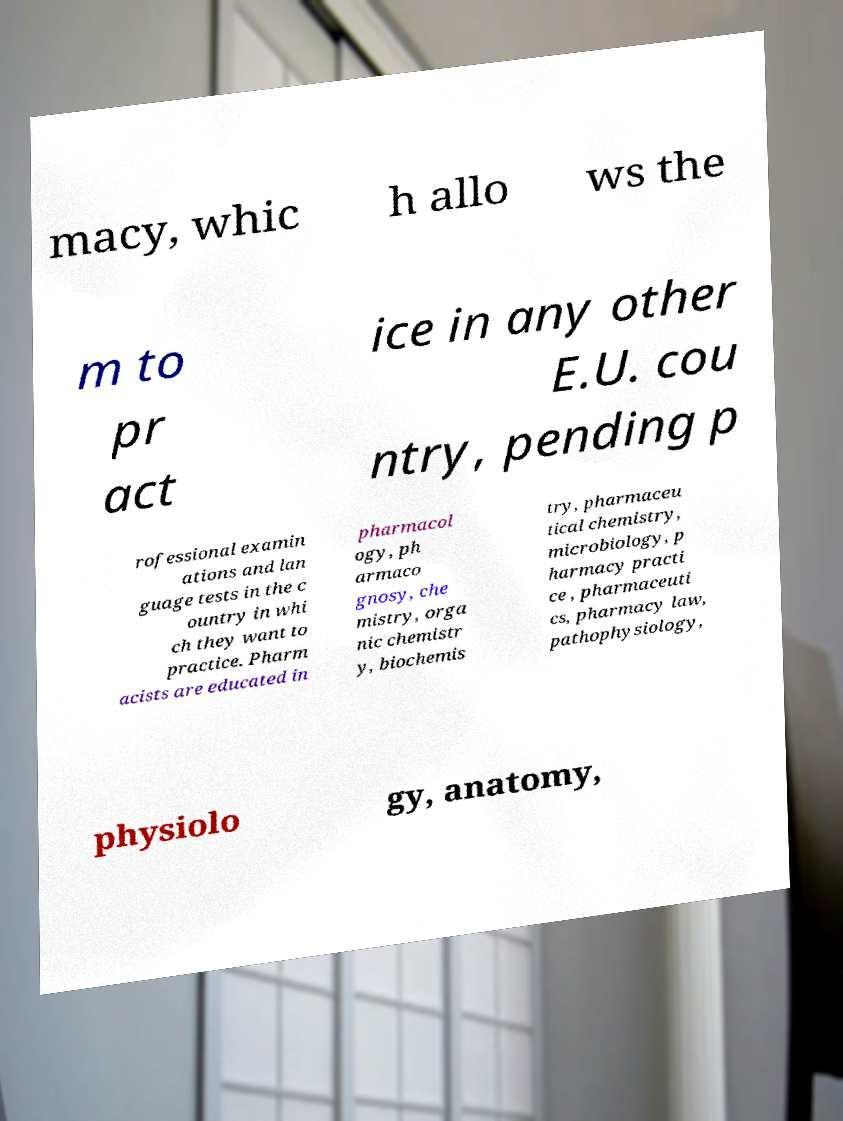I need the written content from this picture converted into text. Can you do that? macy, whic h allo ws the m to pr act ice in any other E.U. cou ntry, pending p rofessional examin ations and lan guage tests in the c ountry in whi ch they want to practice. Pharm acists are educated in pharmacol ogy, ph armaco gnosy, che mistry, orga nic chemistr y, biochemis try, pharmaceu tical chemistry, microbiology, p harmacy practi ce , pharmaceuti cs, pharmacy law, pathophysiology, physiolo gy, anatomy, 